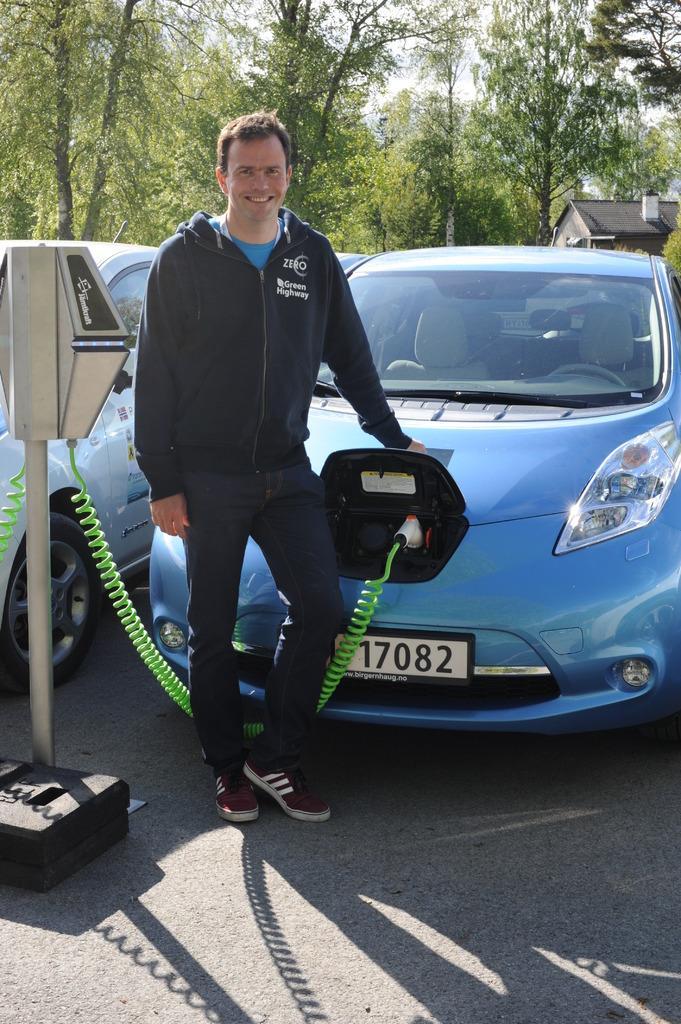Describe this image in one or two sentences. In this image, we can see a person and a few vehicles. We can see the ground and a house. We can also see some trees and the sky. We can see a black colored object. We can see a pole with some objects. 